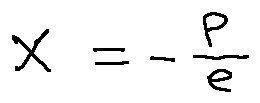Convert formula to latex. <formula><loc_0><loc_0><loc_500><loc_500>X = - \frac { p } { e }</formula> 